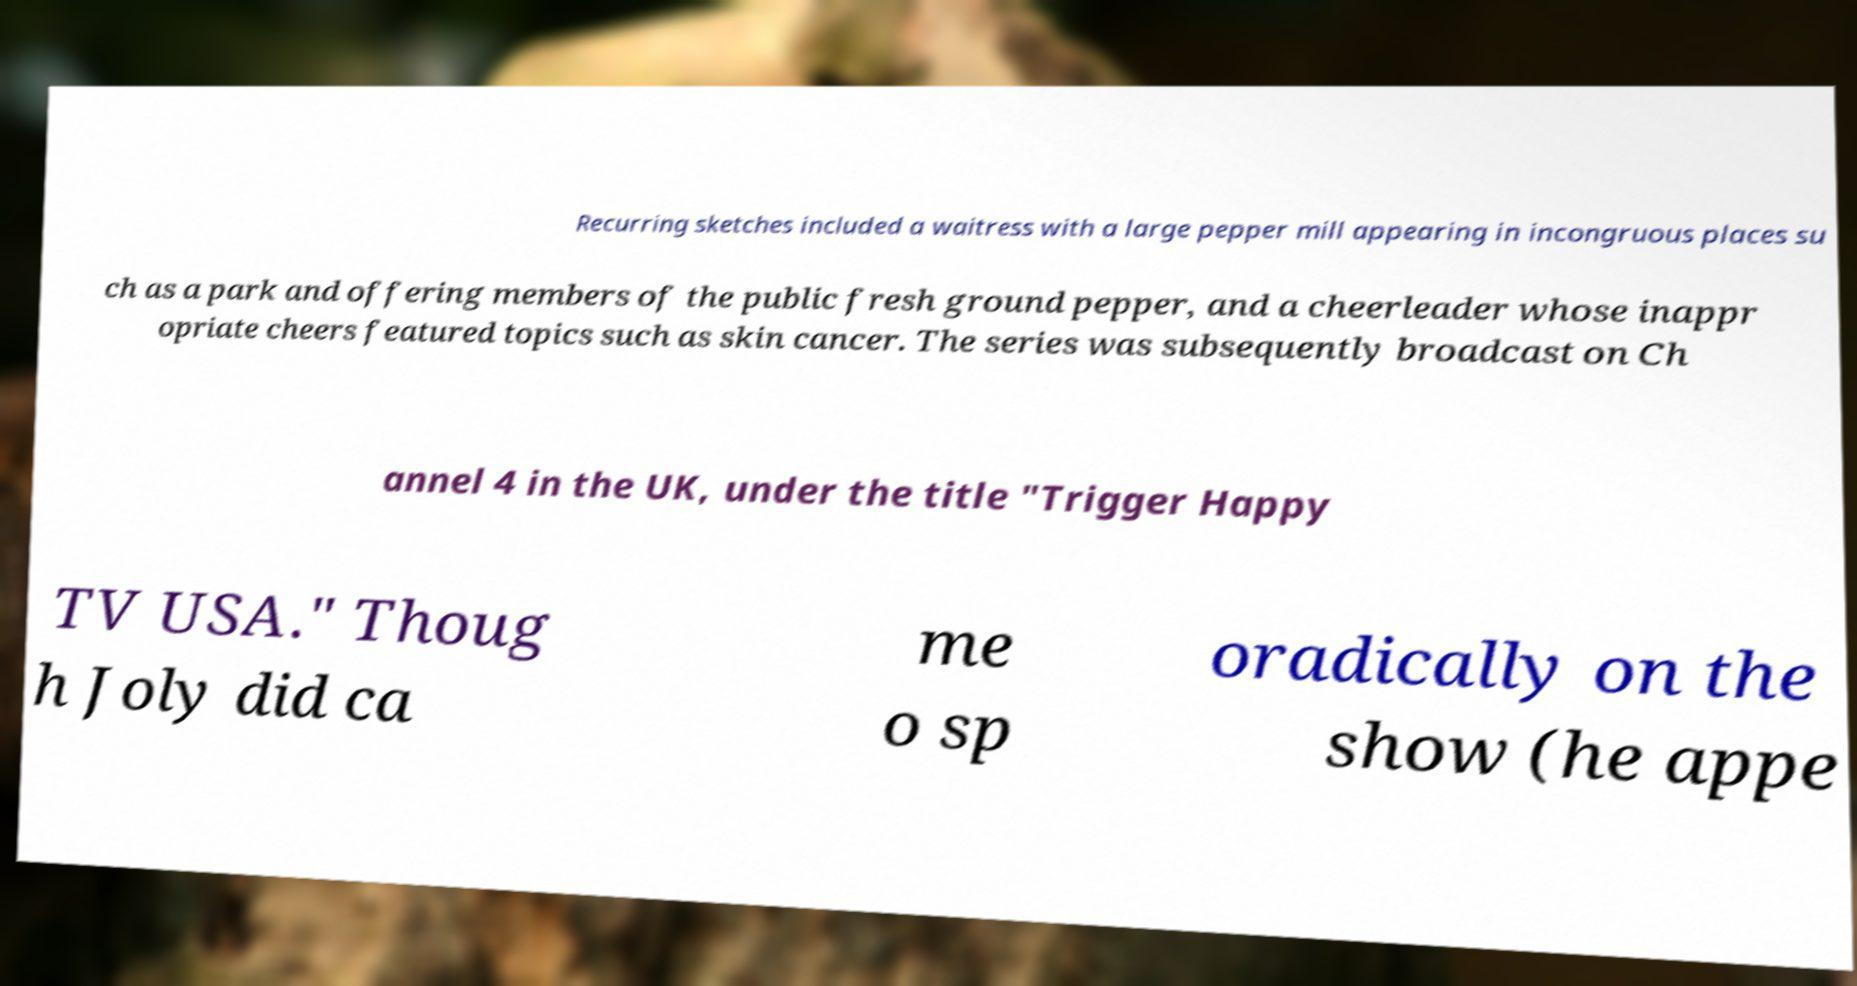For documentation purposes, I need the text within this image transcribed. Could you provide that? Recurring sketches included a waitress with a large pepper mill appearing in incongruous places su ch as a park and offering members of the public fresh ground pepper, and a cheerleader whose inappr opriate cheers featured topics such as skin cancer. The series was subsequently broadcast on Ch annel 4 in the UK, under the title "Trigger Happy TV USA." Thoug h Joly did ca me o sp oradically on the show (he appe 